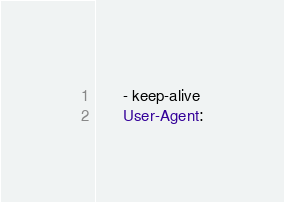<code> <loc_0><loc_0><loc_500><loc_500><_YAML_>      - keep-alive
      User-Agent:</code> 